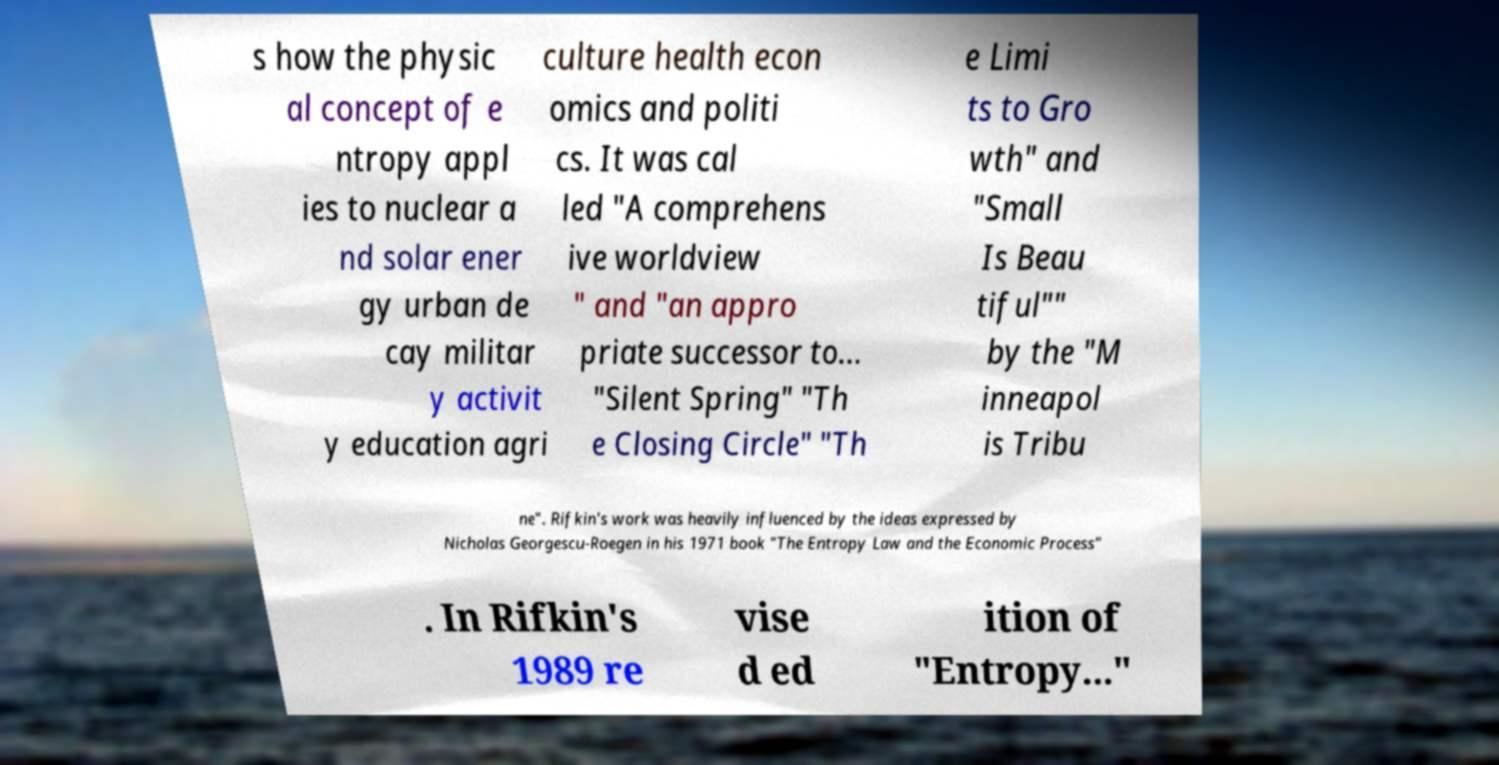For documentation purposes, I need the text within this image transcribed. Could you provide that? s how the physic al concept of e ntropy appl ies to nuclear a nd solar ener gy urban de cay militar y activit y education agri culture health econ omics and politi cs. It was cal led "A comprehens ive worldview " and "an appro priate successor to... "Silent Spring" "Th e Closing Circle" "Th e Limi ts to Gro wth" and "Small Is Beau tiful"" by the "M inneapol is Tribu ne". Rifkin's work was heavily influenced by the ideas expressed by Nicholas Georgescu-Roegen in his 1971 book "The Entropy Law and the Economic Process" . In Rifkin's 1989 re vise d ed ition of "Entropy..." 